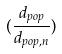<formula> <loc_0><loc_0><loc_500><loc_500>( \frac { d _ { p o p } } { d _ { p o p , n } } )</formula> 